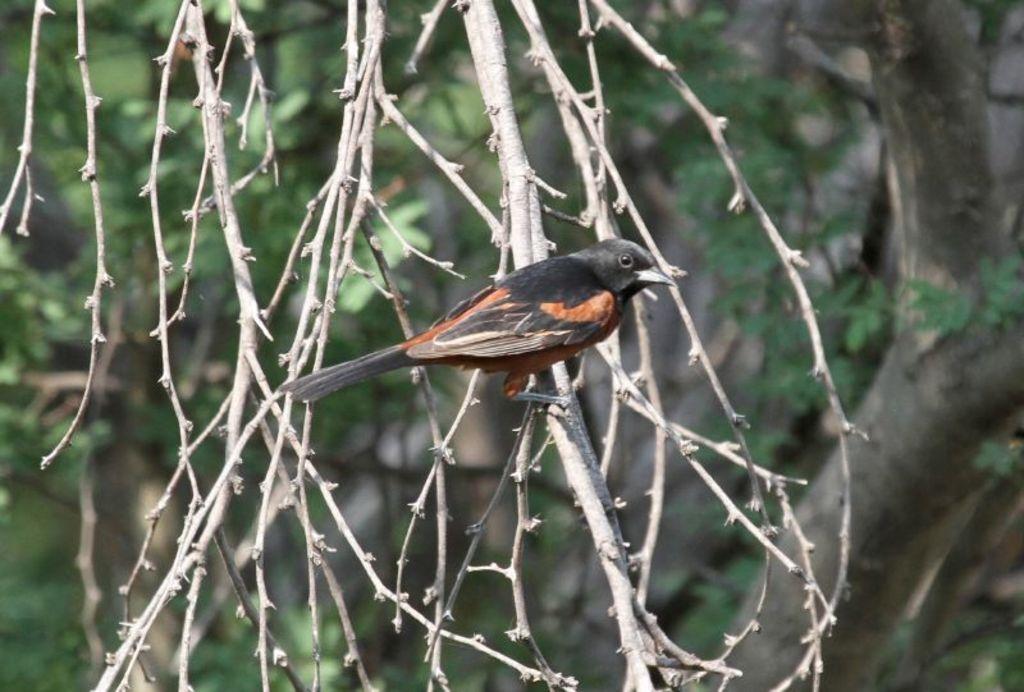Can you describe this image briefly? In the center of the image there is a bird on the tree. In the background there are trees. 